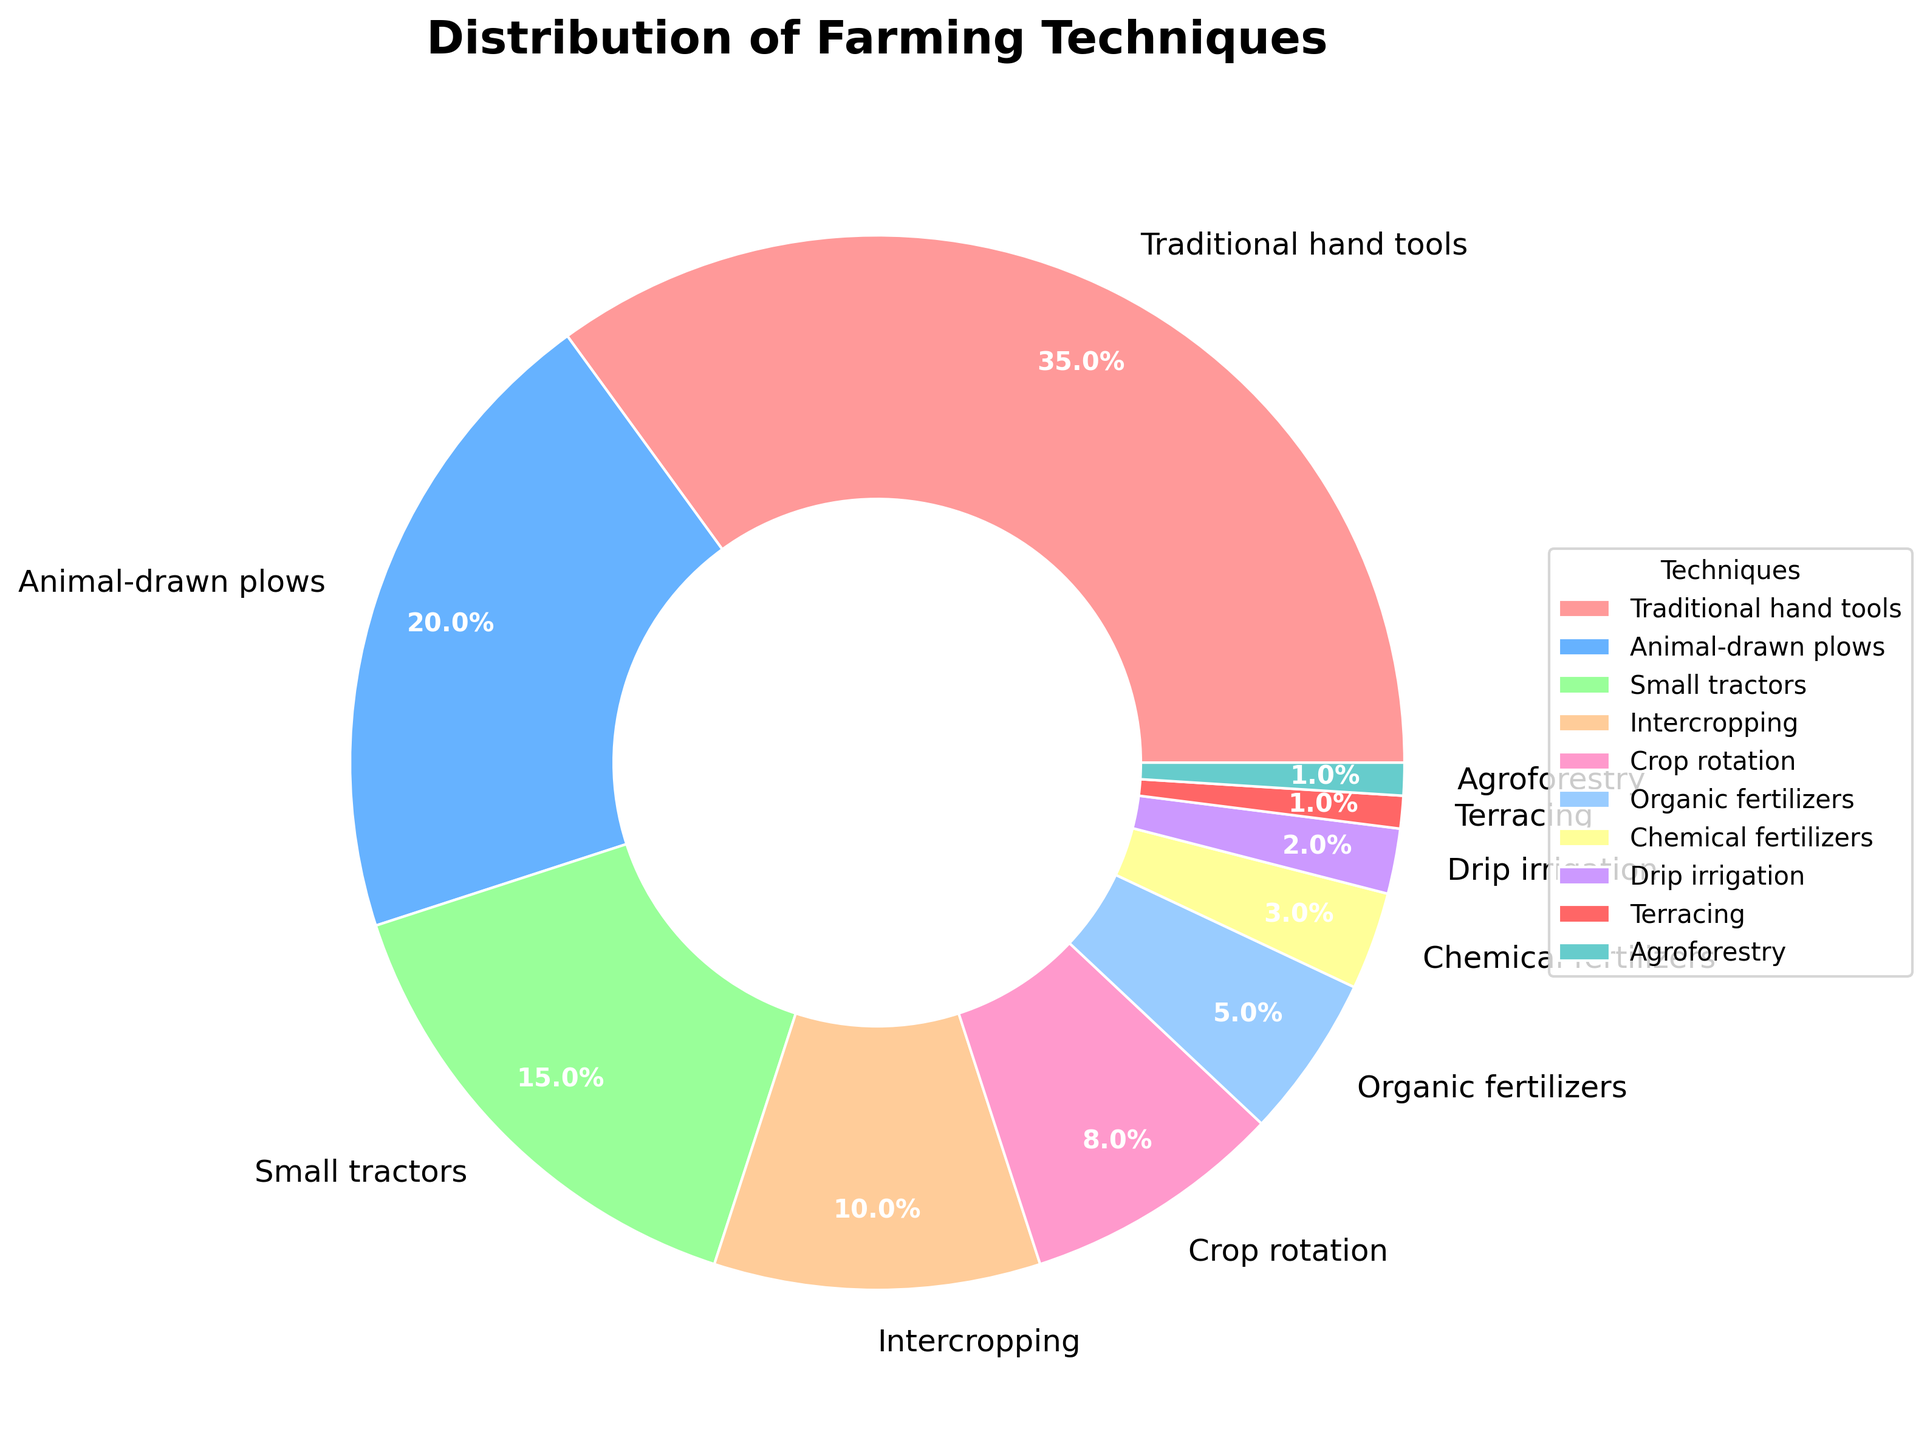Which farming technique has the largest share? The largest segment in the pie chart represents Traditional hand tools, which occupies 35% of the total share.
Answer: Traditional hand tools Which two farming techniques combined make up more than half of the pie chart? Traditional hand tools (35%) and Animal-drawn plows (20%) combined make up 35% + 20% = 55% of the pie chart, which is more than half.
Answer: Traditional hand tools and Animal-drawn plows What percentage do the least common farming techniques, combined, contribute? The least common techniques are Terracing and Agroforestry, each contributing 1%. Combined, they contribute 1% + 1% = 2%.
Answer: 2% Which farming techniques have a greater share than Small tractors? Traditional hand tools (35%) and Animal-drawn plows (20%) have a greater share than Small tractors (15%).
Answer: Traditional hand tools and Animal-drawn plows How much more common are Traditional hand tools compared to Organic fertilizers? Traditional hand tools have a 35% share, while Organic fertilizers have a 5% share. The difference is 35% - 5% = 30%.
Answer: 30% What is the combined percentage of Crop rotation, Organic fertilizers, and Chemical fertilizers? Crop rotation has 8%, Organic fertilizers have 5%, and Chemical fertilizers have 3%. Combined, they contribute 8% + 5% + 3% = 16%.
Answer: 16% Is Drip irrigation more or less common than Chemical fertilizers? Drip irrigation has a 2% share, while Chemical fertilizers have a 3% share. Therefore, Drip irrigation is less common.
Answer: Less common Which technique is represented by the smallest wedge in the pie chart, and what is its percentage? Both Terracing and Agroforestry are represented by the smallest wedges; each has a 1% share.
Answer: Terracing and Agroforestry, 1% What is the average percentage share of the techniques with more than 10%? The techniques with more than 10% are Traditional hand tools (35%), Animal-drawn plows (20%), and Small tractors (15%). Their average percentage is (35% + 20% + 15%) / 3 = 70% / 3 ≈ 23.33%.
Answer: 23.33% 